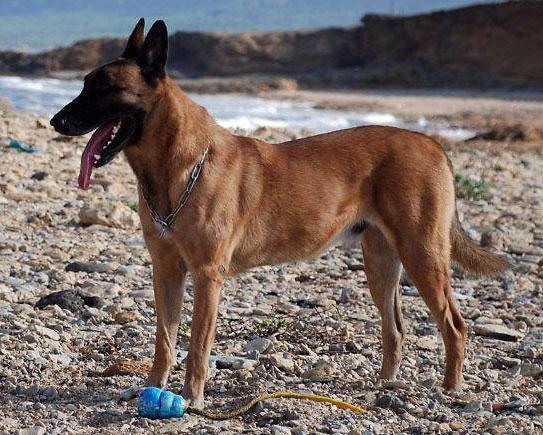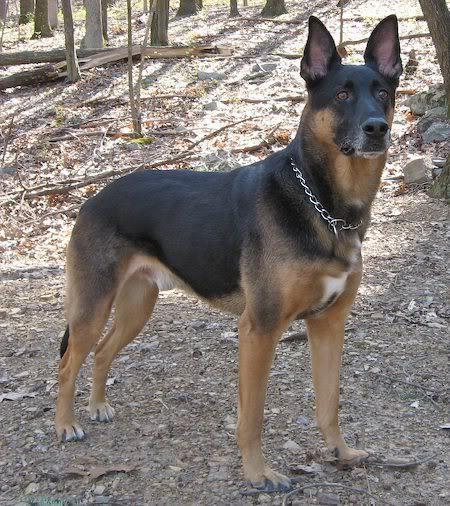The first image is the image on the left, the second image is the image on the right. For the images shown, is this caption "There are at most five dogs." true? Answer yes or no. Yes. 